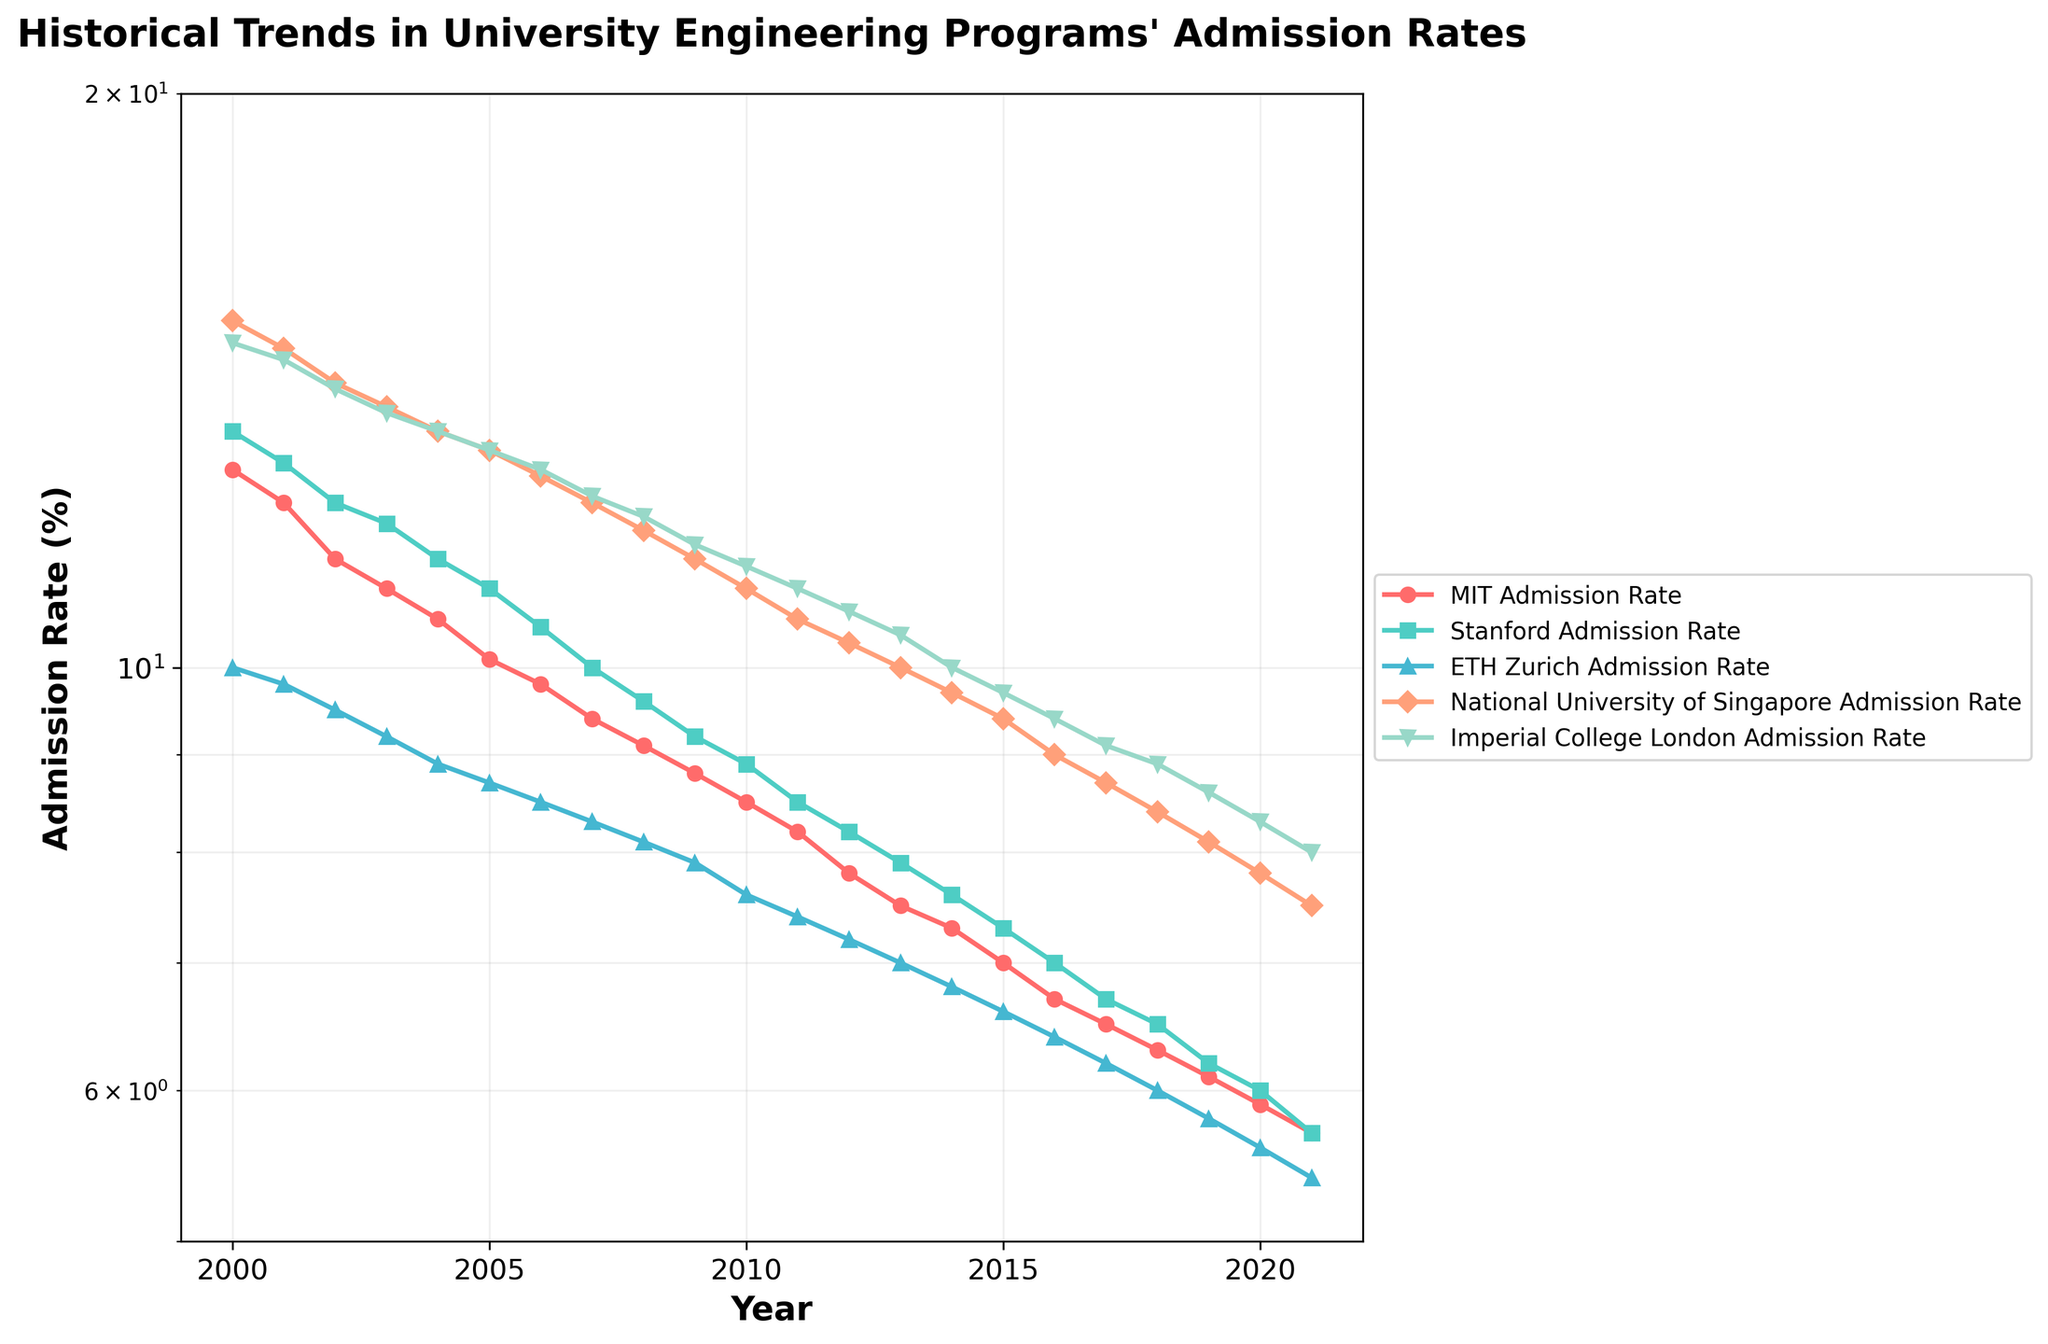What is the admission rate trend for MIT from 2000 to 2021? The figure shows that the MIT admission rate decreased each year from 2000 to 2021. In 2000, it was approximately 12.7%, and by 2021, it had decreased to around 5.7%.
Answer: Decreasing Which university had the highest admission rate in 2000? Looking at the figure, the National University of Singapore had the highest admission rate in 2000, which was around 15.2%.
Answer: National University of Singapore By how much did the admission rate for ETH Zurich change from 2000 to 2021? The admission rate for ETH Zurich in 2000 was approximately 10%. By 2021, it had decreased to around 5.4%. The change in admission rate is thus 10% - 5.4% = 4.6%.
Answer: 4.6% Which university's admission rate decreased the most from 2000 to 2021? Comparing the admission rate decrease from 2000 to 2021 for all universities, MIT saw the most significant decrease from 12.7% to 5.7%, making the reduction 12.7% - 5.7% = 7%.
Answer: MIT In which year did Stanford and Imperial College London have the same admission rate? From the figure, it appears that Stanford and Imperial College London had the same admission rate around the year 2021, both at approximately 5.7%.
Answer: 2021 What was the rate of decline in admission rates for National University of Singapore between 2000 and 2021? The National University of Singapore's admission rate changed from 15.2% in 2000 to 7.5% in 2021. To find the rate of decline, ((15.2% - 7.5%) / 15.2%) * 100 = 50.66%.
Answer: 50.66% Between which two consecutive years was the largest decline in admission rate for MIT? By examining the difference in the admission rate for MIT between consecutive years, the largest decline is from 2000 (12.7%) to 2001 (12.2%), which is a change of 0.5%.
Answer: 2000 and 2001 Which university had the smallest decrease in admission rates from 2000 to 2021? Comparing the changes for all universities, ETH Zurich had an admission rate decline from 10% in 2000 to 5.4% in 2021, which is a decrease of 4.6%, the smallest among all universities listed.
Answer: ETH Zurich What is the average admission rate for Imperial College London over the period from 2000 to 2021? Adding up the values for all years for Imperial College London and then dividing by the number of years (22), we get the average rate. (14.8+14.5+14.0+13.6+13.3+13.0+12.7+12.3+12.0+11.6+11.3+11.0+10.7+10.4+10.0+9.7+9.4+9.1+8.9+8.6+8.3)/22 = ~11.22%.
Answer: ~11.22% How did the admission rates for MIT and Stanford compare in the year 2015? In 2015, the admission rate for MIT was approximately 7.0%, while for Stanford it was around 7.3%. Thus, Stanford's admission rate was higher than MIT's that year.
Answer: Stanford had a higher rate 